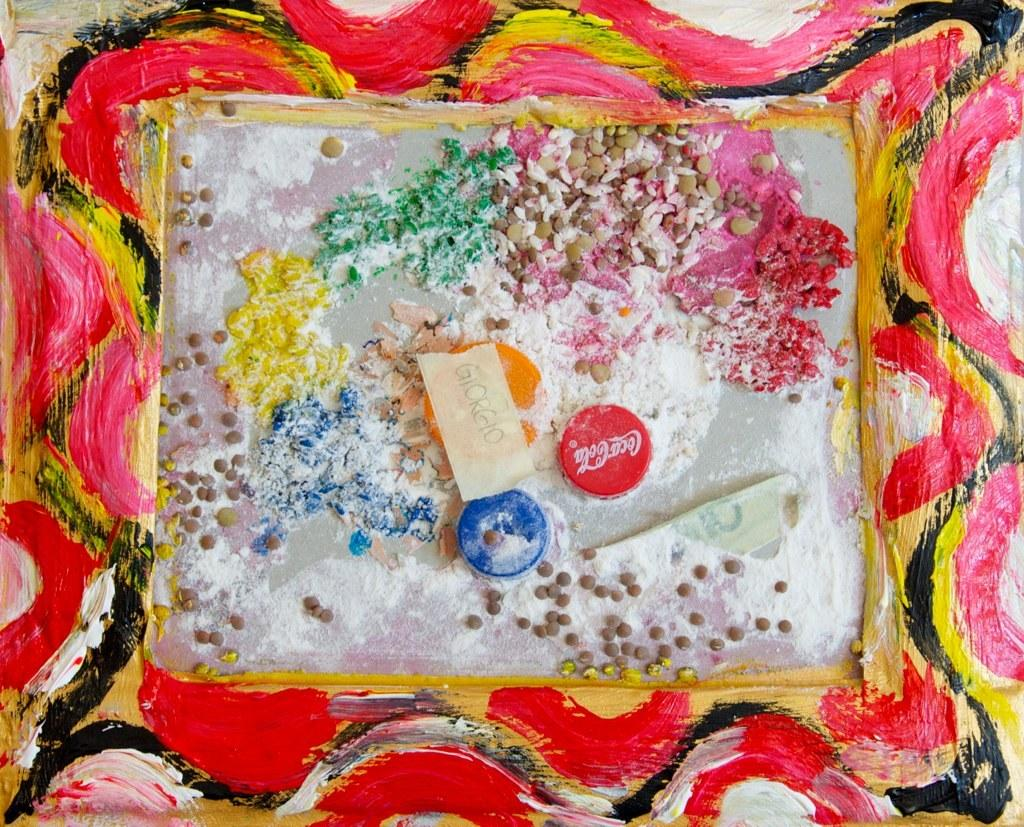What is the main object in the image? There is a frame in the image. How is the frame decorated? The frame is painted. What can be found in the center of the frame? There are bottle caps and other items in the center of the frame. What type of instrument can be heard playing in the background of the image? There is no instrument playing in the background of the image, as it is a still image of a frame with bottle caps and other items. How many frogs are visible in the image? There are no frogs present in the image; it features a painted frame with bottle caps and other items. 